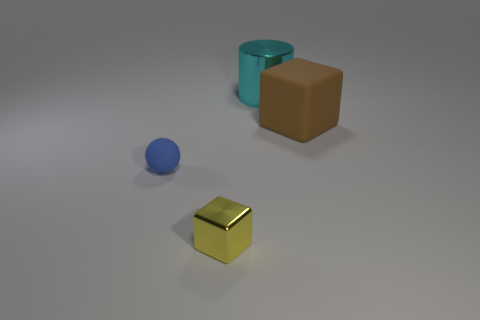Add 3 purple cylinders. How many objects exist? 7 Subtract all spheres. How many objects are left? 3 Subtract all large red cylinders. Subtract all cyan metal things. How many objects are left? 3 Add 4 yellow objects. How many yellow objects are left? 5 Add 4 tiny blue rubber objects. How many tiny blue rubber objects exist? 5 Subtract 0 red blocks. How many objects are left? 4 